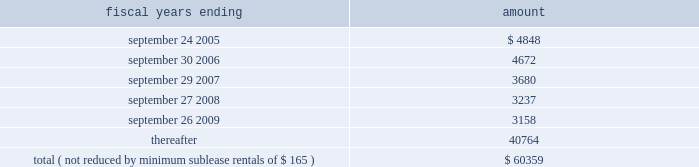Hologic , inc .
Notes to consolidated financial statements 2014 ( continued ) ( in thousands , except per share data ) future minimum lease payments under all the company 2019s operating leases are approximately as follows: .
The company subleases a portion of its bedford facility and has received rental income of $ 277 , $ 410 and $ 682 for fiscal years 2004 , 2003 and 2002 , respectively , which has been recorded as an offset to rent expense in the accompanying statements of income .
Rental expense , net of sublease income , was approximately $ 4660 , $ 4963 , and $ 2462 for fiscal 2004 , 2003 and 2002 , respectively .
Business segments and geographic information the company reports segment information in accordance with sfas no .
131 , disclosures about segments of an enterprise and related information .
Operating segments are identified as components of an enterprise about which separate , discrete financial information is available for evaluation by the chief operating decision maker , or decision-making group , in making decisions how to allocate resources and assess performance .
The company 2019s chief decision-maker , as defined under sfas no .
131 , is the chief executive officer .
To date , the company has viewed its operations and manages its business as four principal operating segments : the manufacture and sale of mammography products , osteoporosis assessment products , digital detectors and other products .
As a result of the company 2019s implementation of a company wide integrated software application in fiscal 2003 , identifiable assets for the four principal operating segments only consist of inventories , intangible assets , and property and equipment .
The company has presented all other assets as corporate assets .
Prior periods have been restated to conform to this presentation .
Intersegment sales and transfers are not significant. .
What was the percentage change in rental expense between 2003 and 2004? 
Computations: ((4660 - 4963) / 4963)
Answer: -0.06105. 